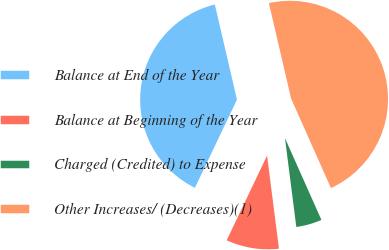Convert chart to OTSL. <chart><loc_0><loc_0><loc_500><loc_500><pie_chart><fcel>Balance at End of the Year<fcel>Balance at Beginning of the Year<fcel>Charged (Credited) to Expense<fcel>Other Increases/ (Decreases)(1)<nl><fcel>39.28%<fcel>9.1%<fcel>4.65%<fcel>46.96%<nl></chart> 